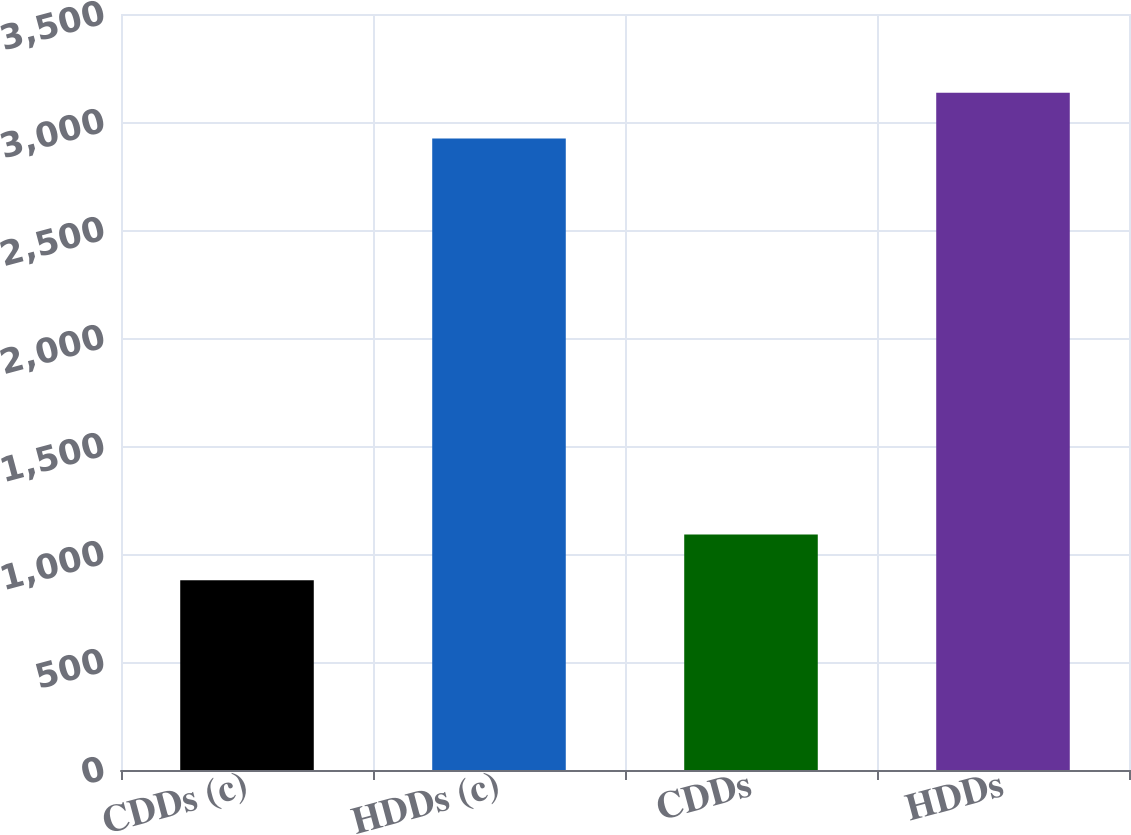Convert chart. <chart><loc_0><loc_0><loc_500><loc_500><bar_chart><fcel>CDDs (c)<fcel>HDDs (c)<fcel>CDDs<fcel>HDDs<nl><fcel>879<fcel>2924<fcel>1089.9<fcel>3134.9<nl></chart> 